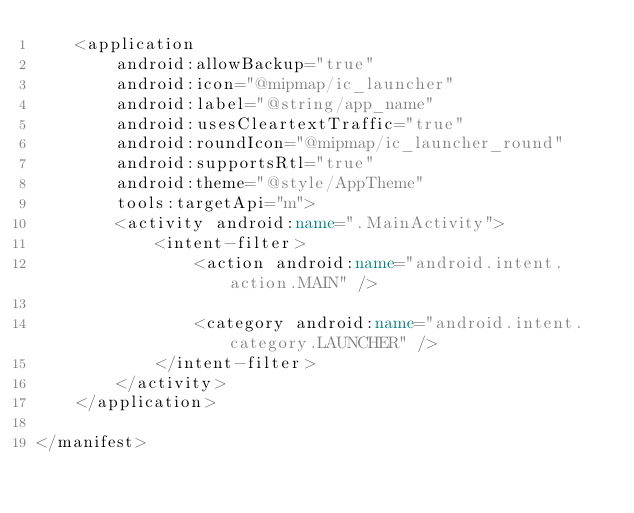<code> <loc_0><loc_0><loc_500><loc_500><_XML_>    <application
        android:allowBackup="true"
        android:icon="@mipmap/ic_launcher"
        android:label="@string/app_name"
        android:usesCleartextTraffic="true"
        android:roundIcon="@mipmap/ic_launcher_round"
        android:supportsRtl="true"
        android:theme="@style/AppTheme"
        tools:targetApi="m">
        <activity android:name=".MainActivity">
            <intent-filter>
                <action android:name="android.intent.action.MAIN" />

                <category android:name="android.intent.category.LAUNCHER" />
            </intent-filter>
        </activity>
    </application>

</manifest></code> 